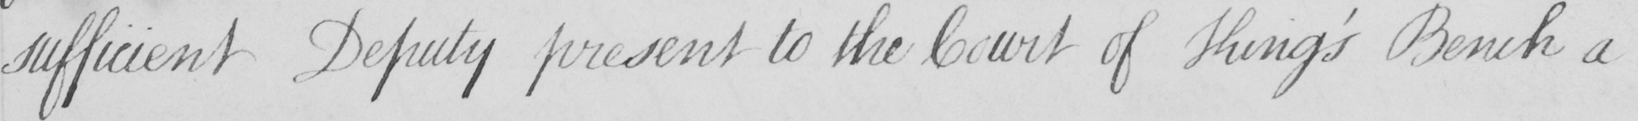What is written in this line of handwriting? sufficient Deputy present to the Court of King ' s Bench a 